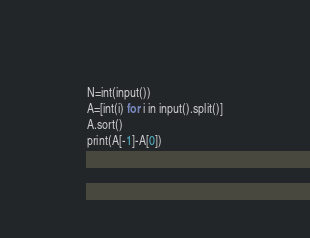Convert code to text. <code><loc_0><loc_0><loc_500><loc_500><_Python_>N=int(input())
A=[int(i) for i in input().split()]
A.sort()
print(A[-1]-A[0])</code> 